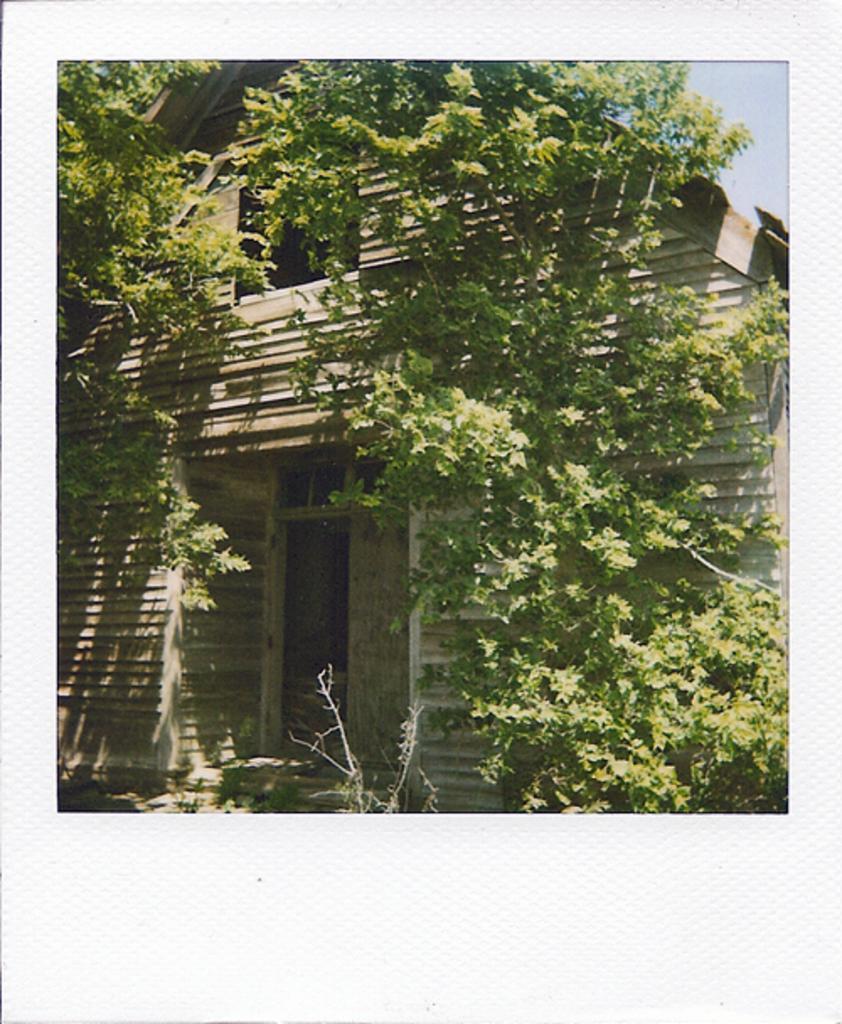How would you summarize this image in a sentence or two? This image consists of a picture. In the middle of the image there is a wooden house with walls, a window and a door. There are a few trees and plants with green leaves. At the top right of the image there is a sky. 